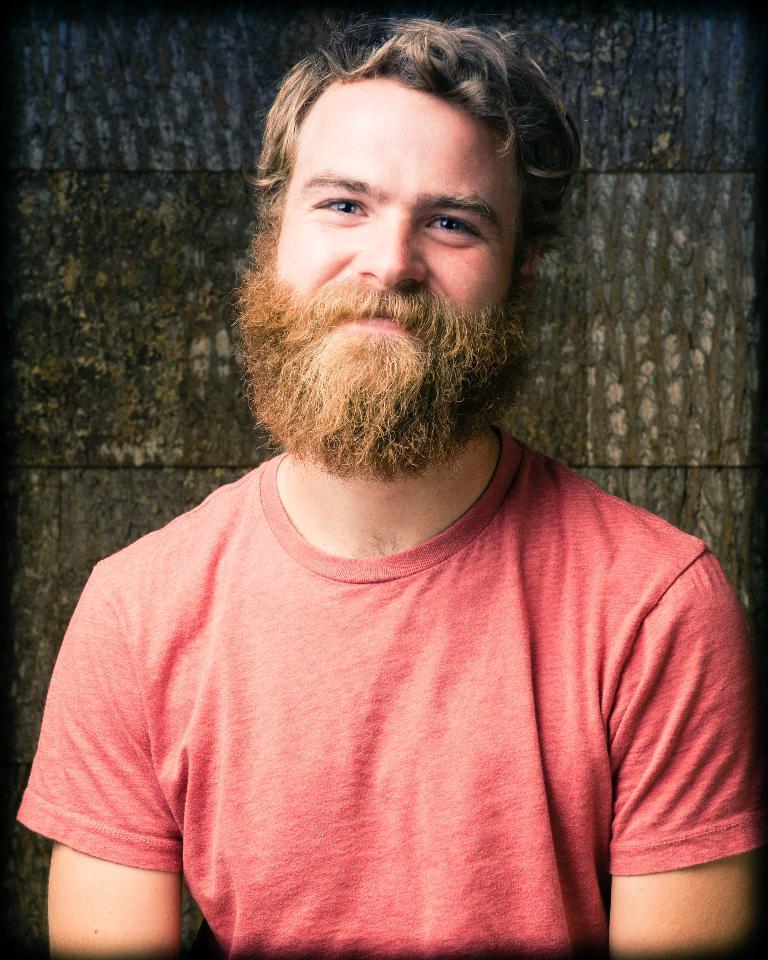How would you summarize this image in a sentence or two? In this image I can see a person wearing red color dress. Background I can see the wall in brown color. 